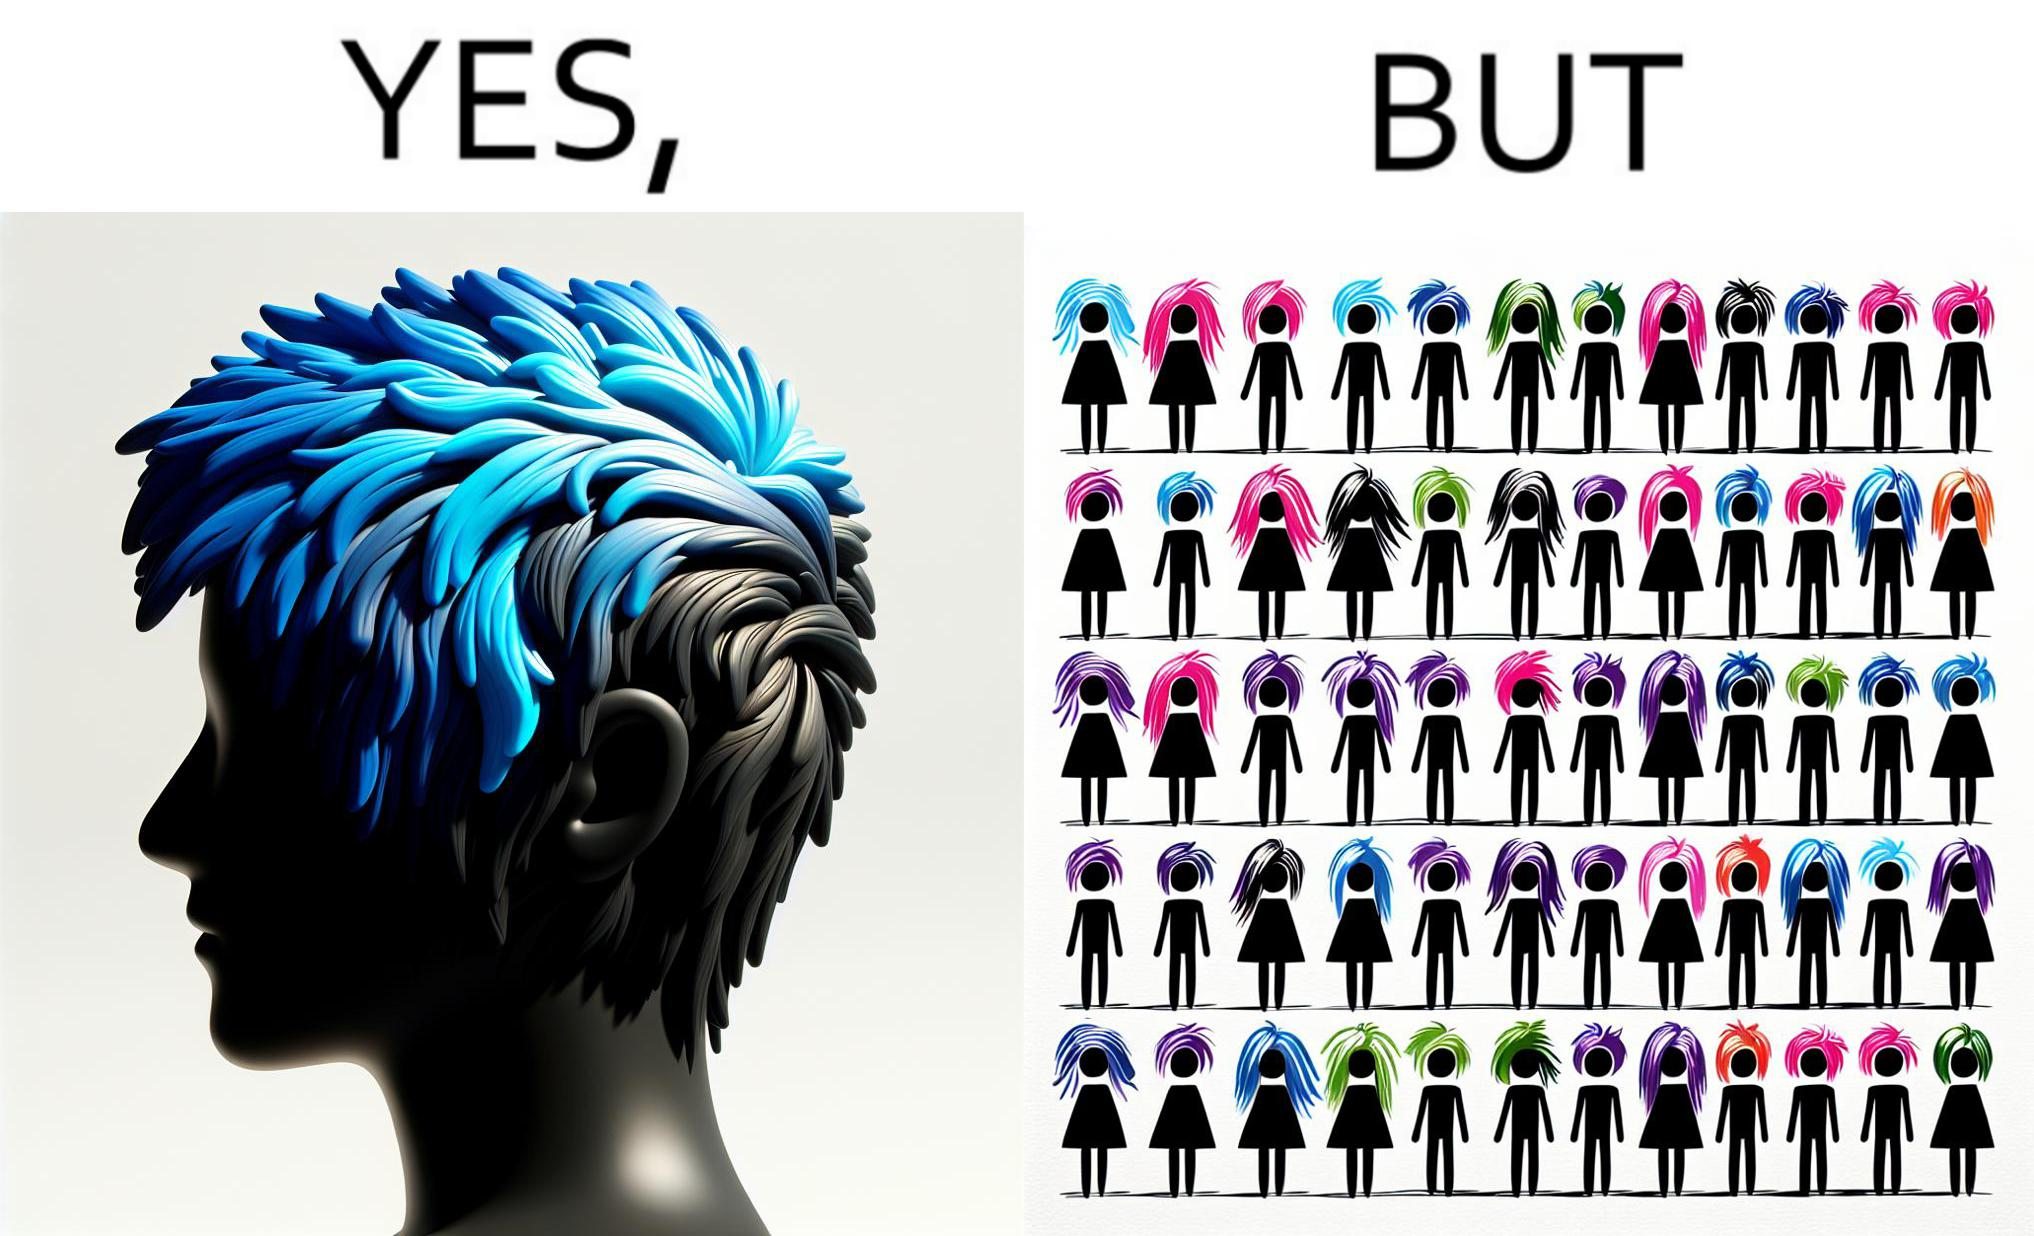Is there satirical content in this image? Yes, this image is satirical. 